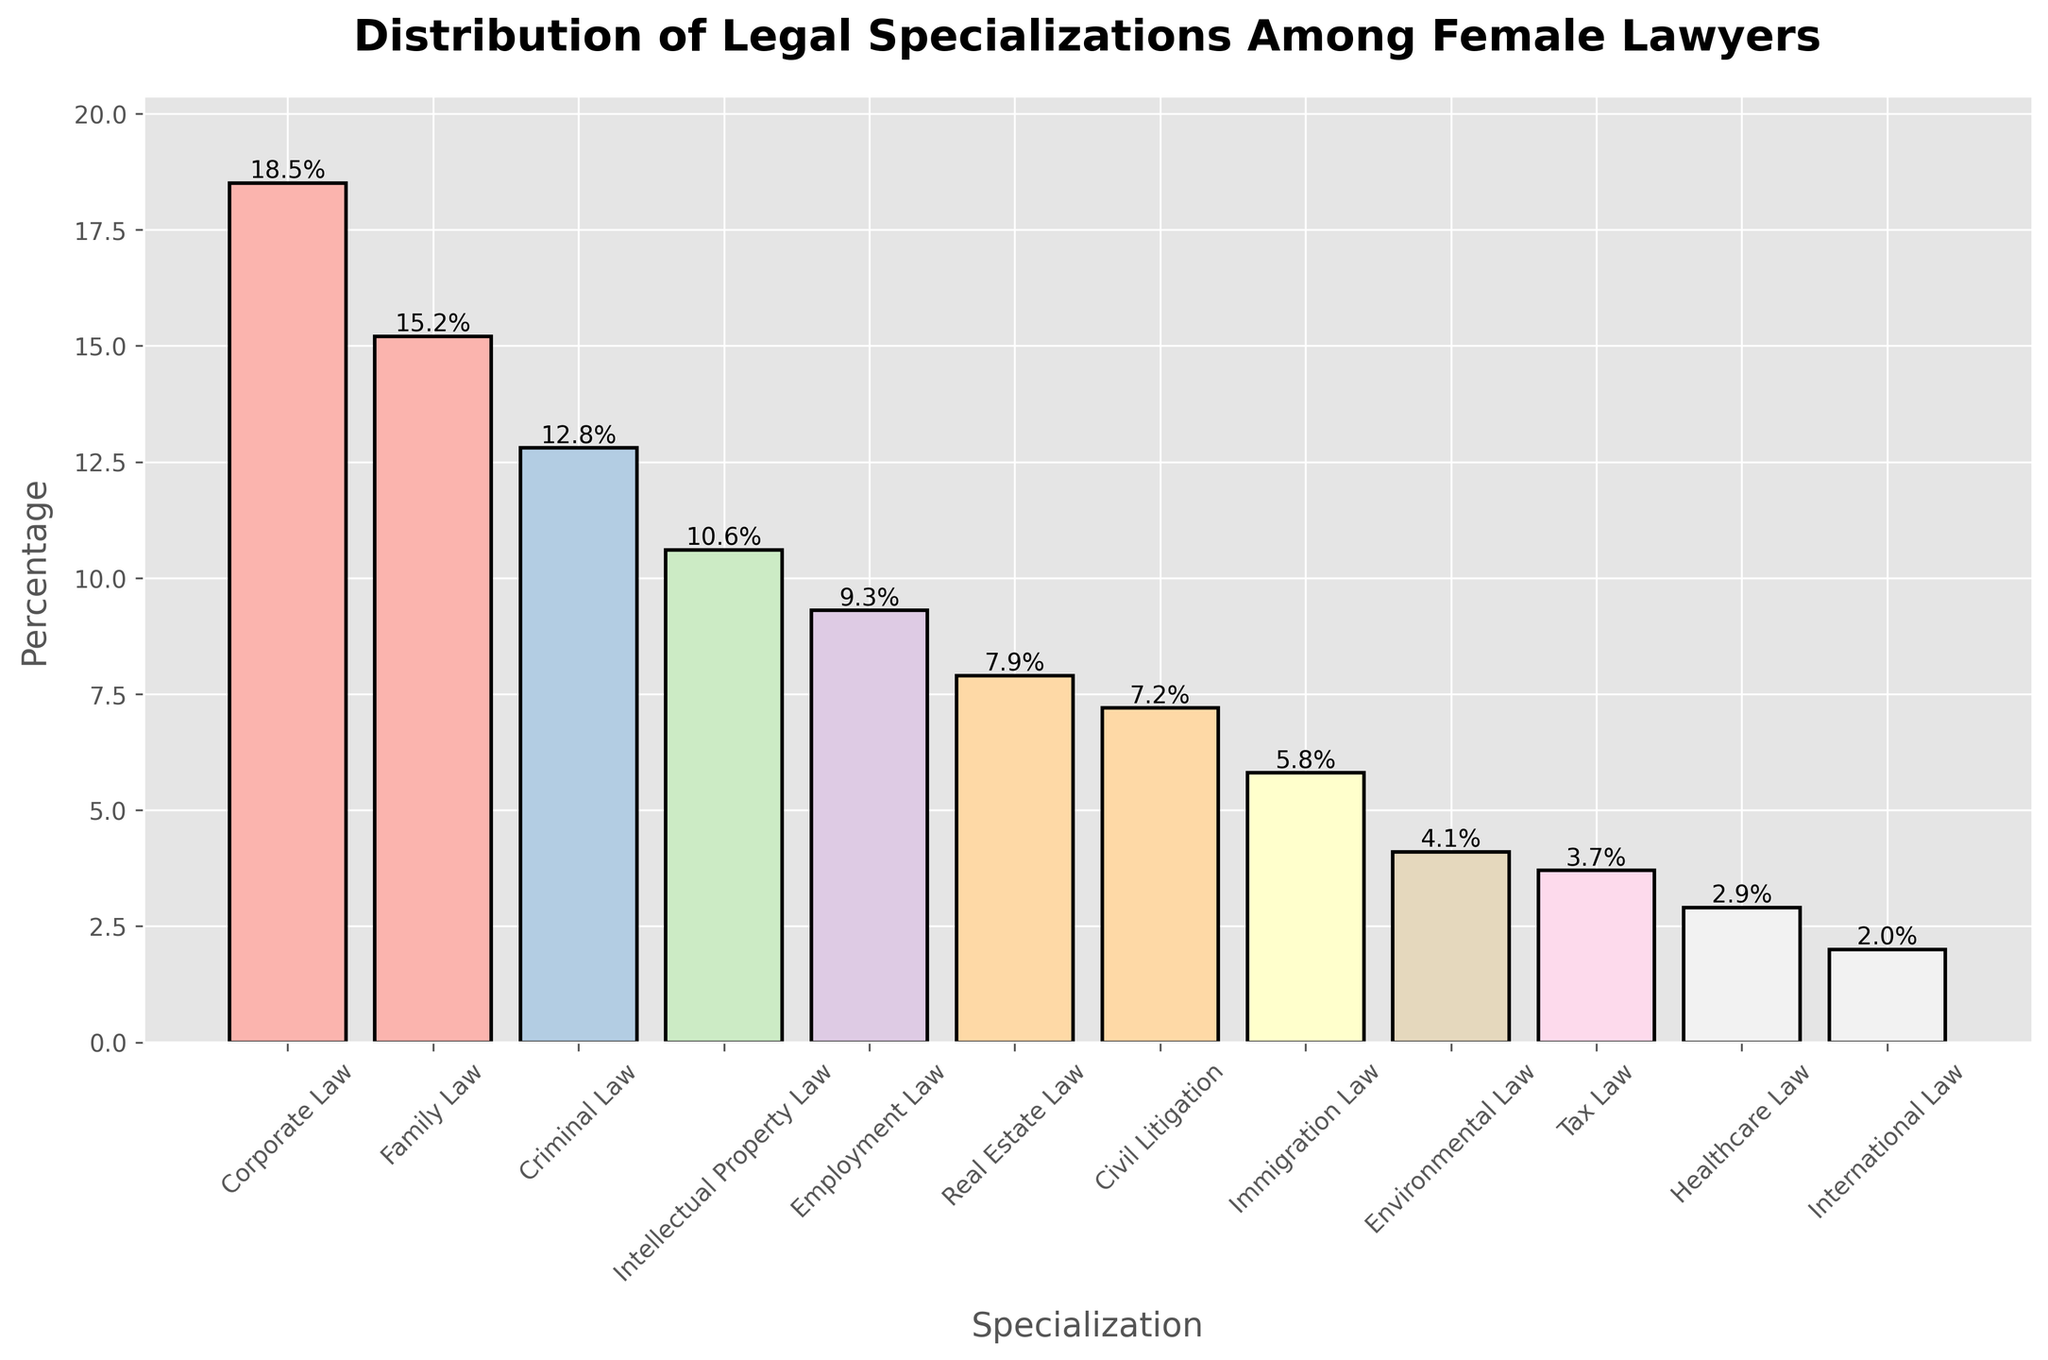Which specialization has the highest percentage among female lawyers? By observing the heights of the bars, the tallest bar represents the specialization with the highest percentage. This is Corporate Law.
Answer: Corporate Law Which specialization ranks second in terms of percentage among female lawyers? By comparing the heights, the second tallest bar represents Family Law.
Answer: Family Law What is the combined percentage of female lawyers in Corporate Law and Family Law? Sum the percentages of Corporate Law (18.5%) and Family Law (15.2%). 18.5% + 15.2% = 33.7%.
Answer: 33.7% Which areas of law have a percentage less than 5%? Observing the bars below the 5% mark, these specializations are Environmental Law, Tax Law, Healthcare Law, and International Law.
Answer: Environmental Law, Tax Law, Healthcare Law, International Law How many specializations have a percentage greater than 10%? Identify the bars higher than 10%: Corporate Law, Family Law, Criminal Law, and Intellectual Property Law. There are 4 such bars.
Answer: 4 What is the difference in percentage between Criminal Law and Employment Law? Subtract the percentage of Employment Law (9.3%) from Criminal Law (12.8%). 12.8% - 9.3% = 3.5%.
Answer: 3.5% Is the percentage of female lawyers in Real Estate Law higher than in Civil Litigation? Compare the heights of the bars for Real Estate Law (7.9%) and Civil Litigation (7.2%). Yes, Real Estate Law is higher.
Answer: Yes What is the average percentage of female lawyers across all specializations shown? Sum all percentages: 18.5 + 15.2 + 12.8 + 10.6 + 9.3 + 7.9 + 7.2 + 5.8 + 4.1 + 3.7 + 2.9 + 2.0 = 100. Then divide by the number of specializations (12). 100 / 12 = 8.33%.
Answer: 8.33% Which specializations have similar percentages close to 10%? Identify specializations around the 10% mark: Intellectual Property Law (10.6%) and Employment Law (9.3%) are close to each other.
Answer: Intellectual Property Law, Employment Law What is the aggregate percentage of the three least represented legal specializations? Sum the percentages of the three smallest bars: Healthcare Law (2.9%), International Law (2.0%), and Tax Law (3.7%). 2.9% + 2.0% + 3.7% = 8.6%.
Answer: 8.6% 